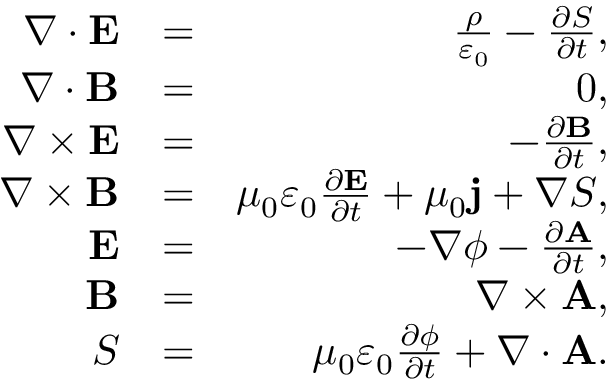Convert formula to latex. <formula><loc_0><loc_0><loc_500><loc_500>\begin{array} { r l r } { \nabla \cdot E } & { = } & { \frac { \rho } { \varepsilon _ { 0 } } - \frac { \partial S } { \partial t } , } \\ { \nabla \cdot B } & { = } & { 0 , } \\ { \nabla \times E } & { = } & { - \frac { \partial B } { \partial t } , } \\ { \nabla \times B } & { = } & { \mu _ { 0 } \varepsilon _ { 0 } \frac { \partial E } { \partial t } + \mu _ { 0 } j + \nabla S , } \\ { E } & { = } & { - \nabla \phi - \frac { \partial A } { \partial t } , } \\ { B } & { = } & { \nabla \times A , } \\ { S } & { = } & { \mu _ { 0 } \varepsilon _ { 0 } \frac { \partial \phi } { \partial t } + \nabla \cdot A . } \end{array}</formula> 